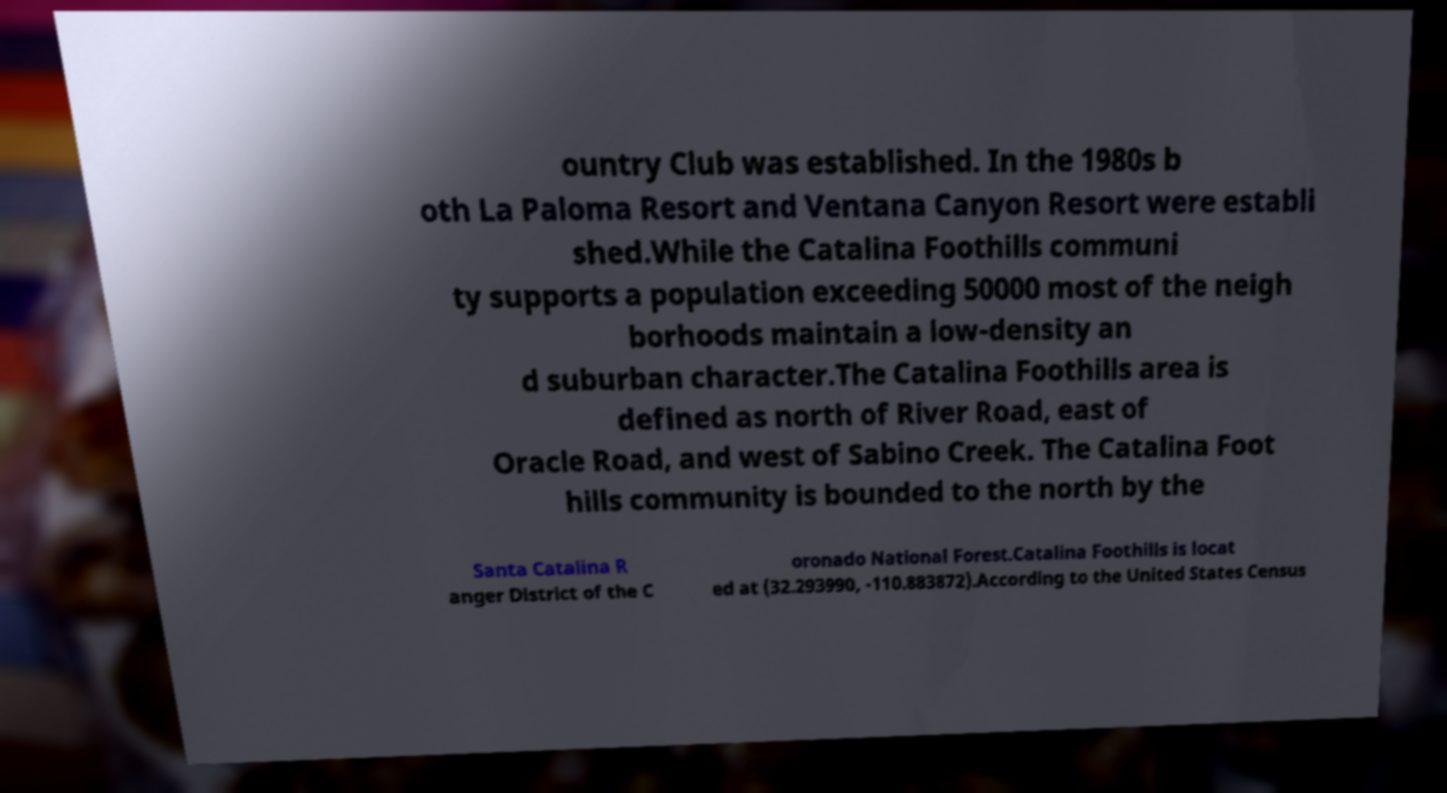Please read and relay the text visible in this image. What does it say? ountry Club was established. In the 1980s b oth La Paloma Resort and Ventana Canyon Resort were establi shed.While the Catalina Foothills communi ty supports a population exceeding 50000 most of the neigh borhoods maintain a low-density an d suburban character.The Catalina Foothills area is defined as north of River Road, east of Oracle Road, and west of Sabino Creek. The Catalina Foot hills community is bounded to the north by the Santa Catalina R anger District of the C oronado National Forest.Catalina Foothills is locat ed at (32.293990, -110.883872).According to the United States Census 